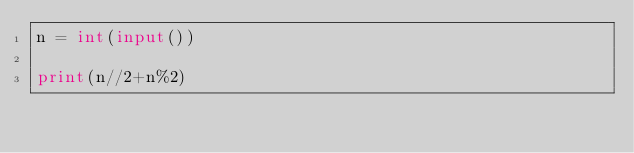<code> <loc_0><loc_0><loc_500><loc_500><_Python_>n = int(input())

print(n//2+n%2)</code> 